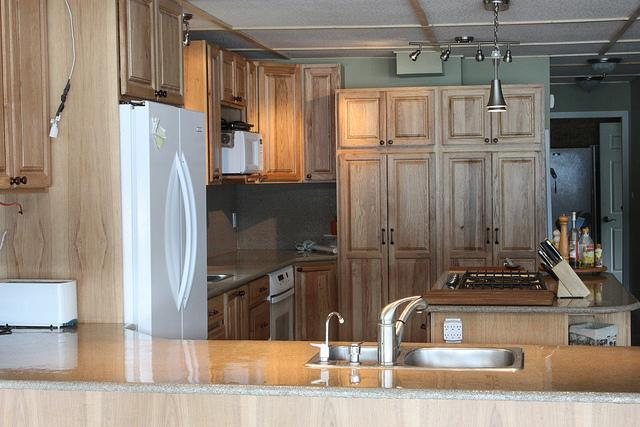Why are there wires sticking out of the wall? Please explain your reasoning. new construction. There seems to be new lighting being put into place in the kitchen. 